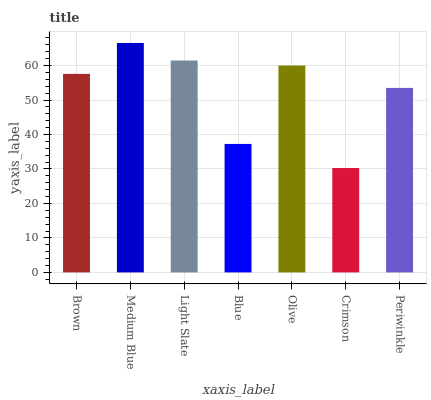Is Crimson the minimum?
Answer yes or no. Yes. Is Medium Blue the maximum?
Answer yes or no. Yes. Is Light Slate the minimum?
Answer yes or no. No. Is Light Slate the maximum?
Answer yes or no. No. Is Medium Blue greater than Light Slate?
Answer yes or no. Yes. Is Light Slate less than Medium Blue?
Answer yes or no. Yes. Is Light Slate greater than Medium Blue?
Answer yes or no. No. Is Medium Blue less than Light Slate?
Answer yes or no. No. Is Brown the high median?
Answer yes or no. Yes. Is Brown the low median?
Answer yes or no. Yes. Is Crimson the high median?
Answer yes or no. No. Is Periwinkle the low median?
Answer yes or no. No. 